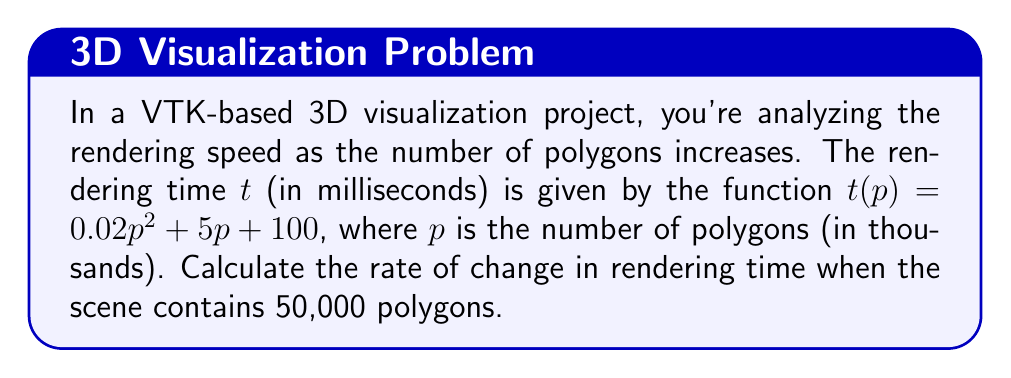What is the answer to this math problem? To find the rate of change in rendering time, we need to calculate the derivative of the given function $t(p)$ and then evaluate it at $p = 50$ (since 50,000 polygons = 50 thousand polygons).

Step 1: Express the function in terms of $p$ (thousands of polygons)
$$t(p) = 0.02p^2 + 5p + 100$$

Step 2: Calculate the derivative of $t(p)$ with respect to $p$
Using the power rule and constant rule of differentiation:
$$\frac{dt}{dp} = 0.04p + 5$$

Step 3: Evaluate the derivative at $p = 50$
$$\frac{dt}{dp}\bigg|_{p=50} = 0.04(50) + 5 = 2 + 5 = 7$$

This means that when the scene contains 50,000 polygons, the rendering time is increasing at a rate of 7 milliseconds per thousand polygons added.
Answer: $7$ ms/thousand polygons 